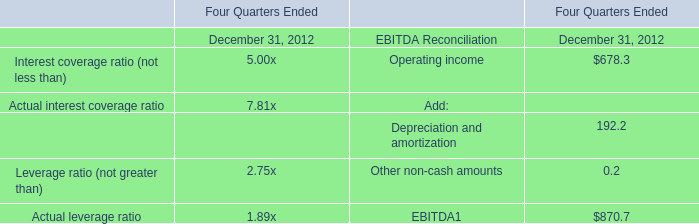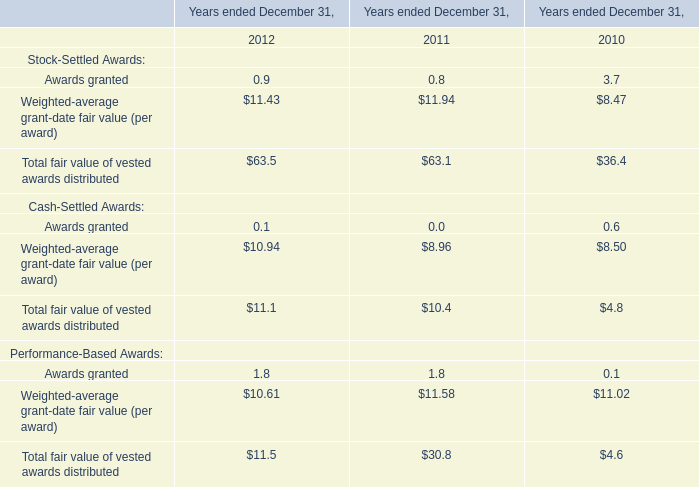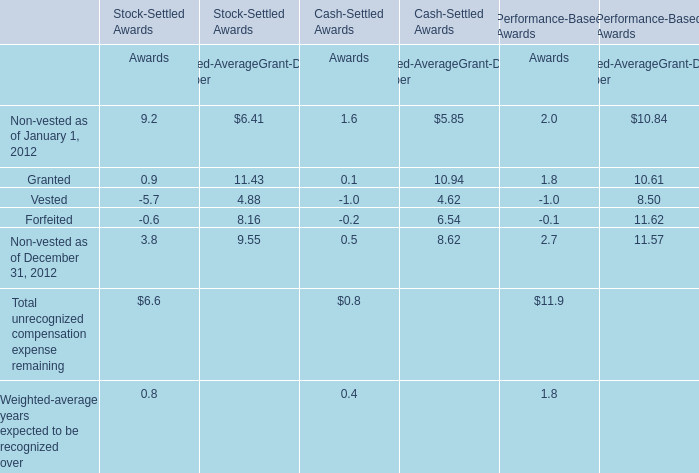What is the average Awards value of Total unrecognized compensation expense remaining between Stock-Settled Awards and Performance-Based Awards? 
Computations: ((6.6 + 11.9) / 2)
Answer: 9.25. 